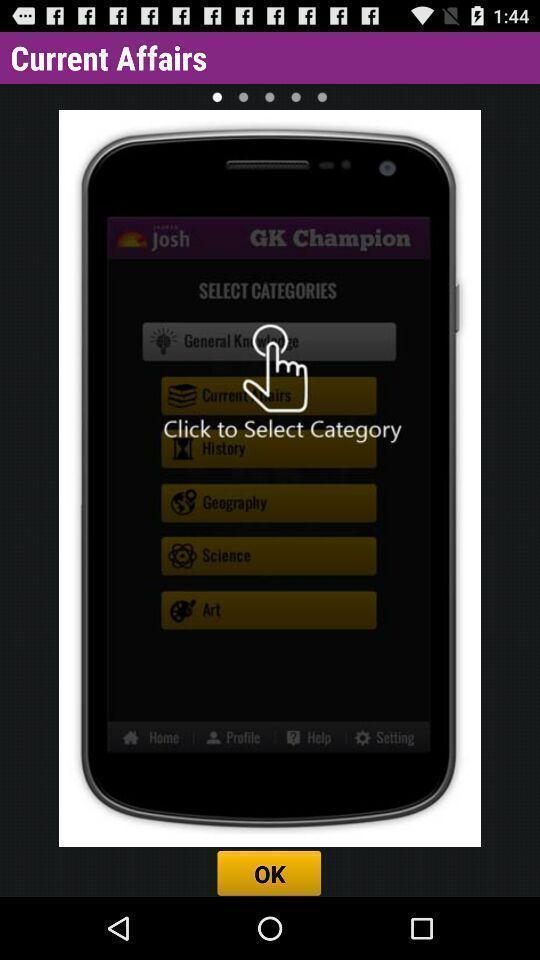Explain what's happening in this screen capture. Pop up to select category in the application. 